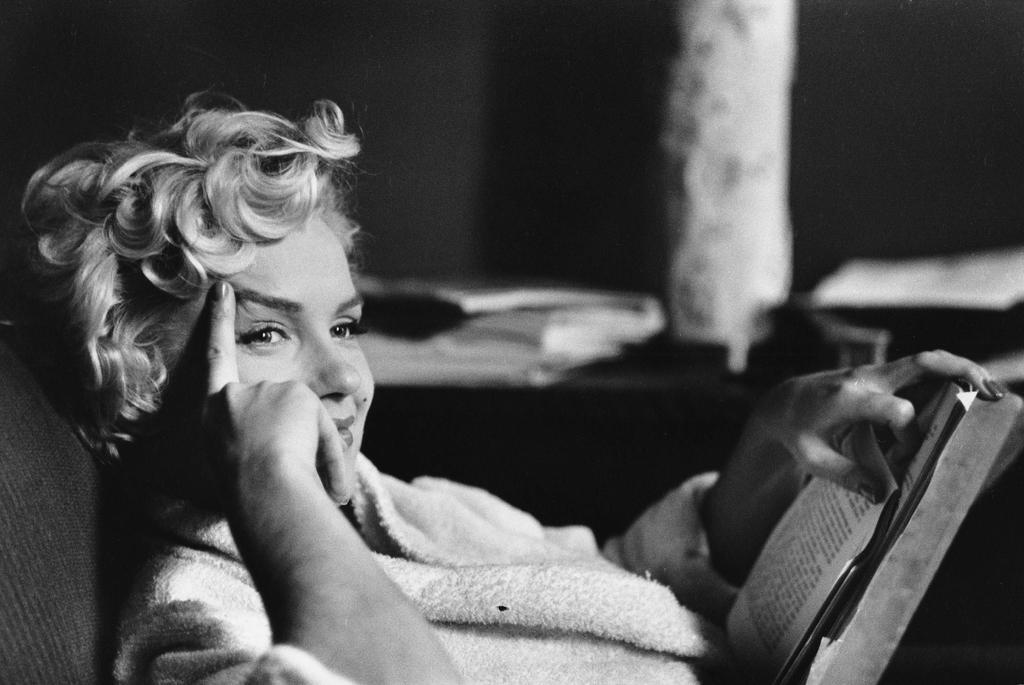Who is present in the image? There is a woman in the image. What is the woman doing in the image? The woman is smiling and holding a book. Can you describe the background of the image? The background of the image is blurry. What type of hill can be seen in the background of the image? There is no hill present in the image; the background is blurry. 